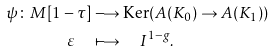Convert formula to latex. <formula><loc_0><loc_0><loc_500><loc_500>\psi \colon M [ 1 - \tau ] & \longrightarrow \text {Ker} ( A ( K _ { 0 } ) \to A ( K _ { 1 } ) ) \\ \varepsilon \quad & \longmapsto \quad I ^ { 1 - g } .</formula> 